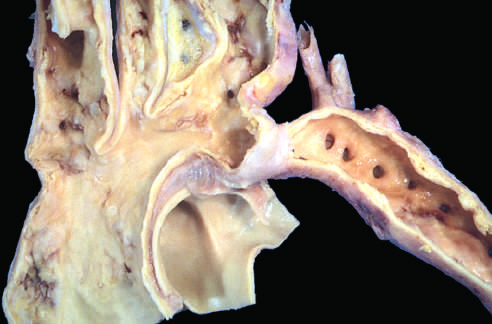what are to the left of the coarctation?
Answer the question using a single word or phrase. The dilated ascending aorta and major branch vessels 